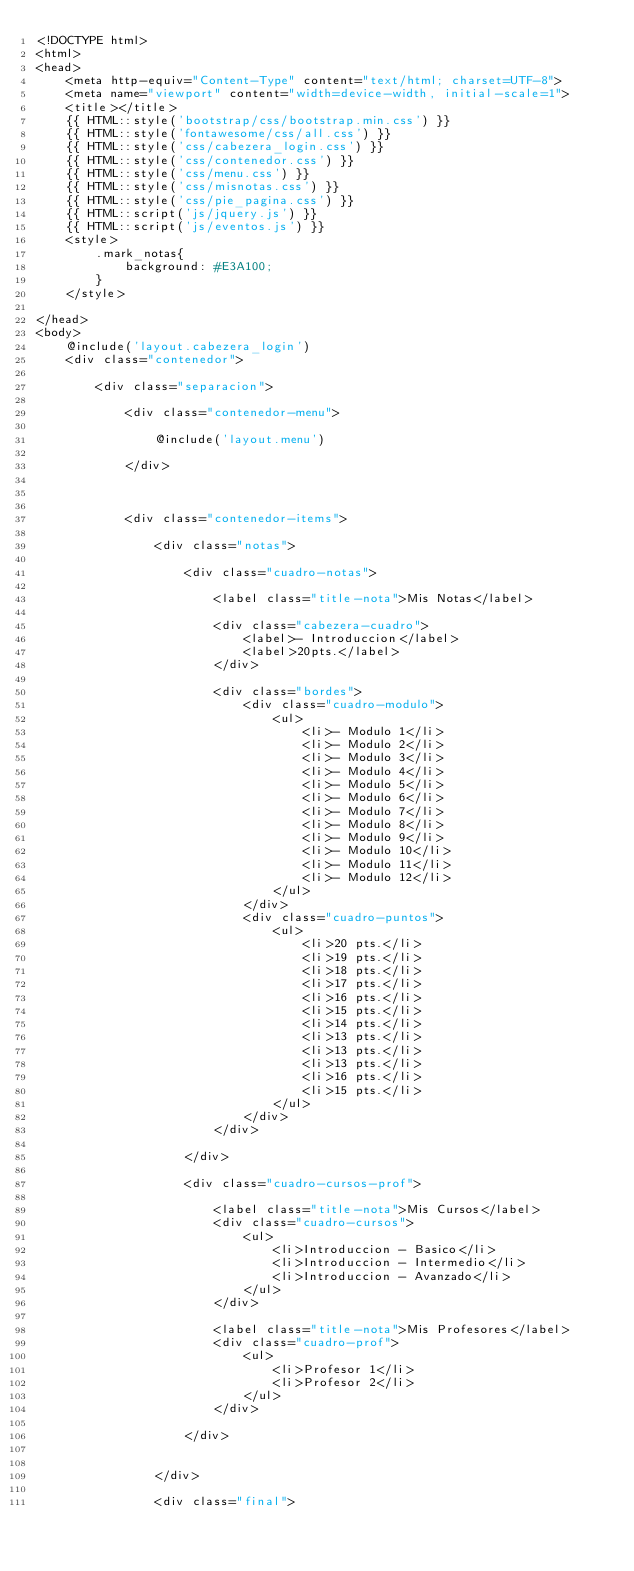Convert code to text. <code><loc_0><loc_0><loc_500><loc_500><_PHP_><!DOCTYPE html>
<html>
<head>
	<meta http-equiv="Content-Type" content="text/html; charset=UTF-8">
	<meta name="viewport" content="width=device-width, initial-scale=1">
	<title></title>
	{{ HTML::style('bootstrap/css/bootstrap.min.css') }}
	{{ HTML::style('fontawesome/css/all.css') }}
	{{ HTML::style('css/cabezera_login.css') }}
	{{ HTML::style('css/contenedor.css') }}
	{{ HTML::style('css/menu.css') }}
	{{ HTML::style('css/misnotas.css') }}
	{{ HTML::style('css/pie_pagina.css') }}
	{{ HTML::script('js/jquery.js') }}
	{{ HTML::script('js/eventos.js') }}
	<style>
		.mark_notas{
			background: #E3A100;
		}
	</style>

</head>
<body>
	@include('layout.cabezera_login')
	<div class="contenedor">

   	    <div class="separacion">

   	    	<div class="contenedor-menu">
   	
				@include('layout.menu')

			</div>

			

			<div class="contenedor-items">
		   		
		   		<div class="notas">
		   			
					<div class="cuadro-notas">

						<label class="title-nota">Mis Notas</label>

						<div class="cabezera-cuadro">
							<label>- Introduccion</label>
							<label>20pts.</label>
						</div>

						<div class="bordes">
							<div class="cuadro-modulo">
								<ul>
									<li>- Modulo 1</li>
									<li>- Modulo 2</li>
									<li>- Modulo 3</li>
									<li>- Modulo 4</li>
									<li>- Modulo 5</li>
									<li>- Modulo 6</li>
									<li>- Modulo 7</li>
									<li>- Modulo 8</li>
									<li>- Modulo 9</li>
									<li>- Modulo 10</li>
									<li>- Modulo 11</li>
									<li>- Modulo 12</li>
								</ul>
							</div>
							<div class="cuadro-puntos">
								<ul>
									<li>20 pts.</li>
									<li>19 pts.</li>
									<li>18 pts.</li>
									<li>17 pts.</li>
									<li>16 pts.</li>
									<li>15 pts.</li>
									<li>14 pts.</li>
									<li>13 pts.</li>
									<li>13 pts.</li>
									<li>13 pts.</li>
									<li>16 pts.</li>
									<li>15 pts.</li>
								</ul>
							</div>
						</div>

					</div>

					<div class="cuadro-cursos-prof">

						<label class="title-nota">Mis Cursos</label>
						<div class="cuadro-cursos">
							<ul>
								<li>Introduccion - Basico</li>
								<li>Introduccion - Intermedio</li>
								<li>Introduccion - Avanzado</li>
							</ul>
						</div>

						<label class="title-nota">Mis Profesores</label>
						<div class="cuadro-prof">
							<ul>
								<li>Profesor 1</li>
								<li>Profesor 2</li>
							</ul>
						</div>

					</div>


		   		</div>

		   		<div class="final">
					</code> 